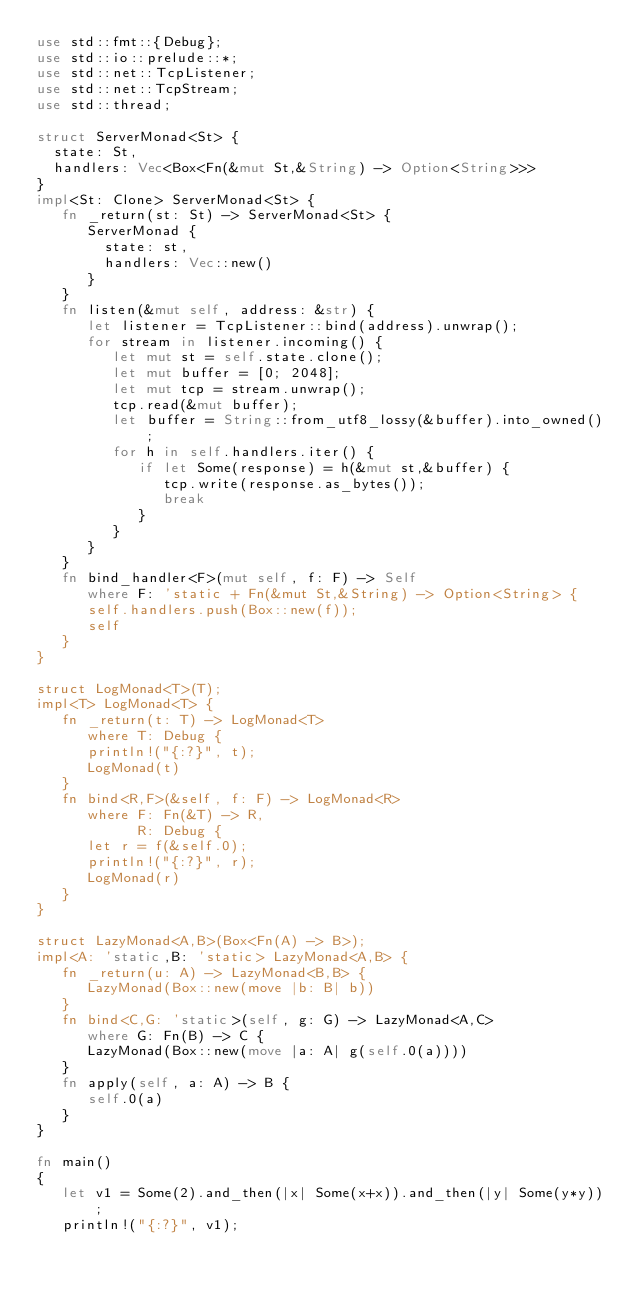Convert code to text. <code><loc_0><loc_0><loc_500><loc_500><_Rust_>use std::fmt::{Debug};
use std::io::prelude::*;
use std::net::TcpListener;
use std::net::TcpStream;
use std::thread;

struct ServerMonad<St> {
  state: St,
  handlers: Vec<Box<Fn(&mut St,&String) -> Option<String>>>
}
impl<St: Clone> ServerMonad<St> {
   fn _return(st: St) -> ServerMonad<St> {
      ServerMonad {
        state: st,
        handlers: Vec::new()
      }
   }
   fn listen(&mut self, address: &str) {
      let listener = TcpListener::bind(address).unwrap();
      for stream in listener.incoming() {
         let mut st = self.state.clone();
         let mut buffer = [0; 2048];
         let mut tcp = stream.unwrap();
         tcp.read(&mut buffer);
         let buffer = String::from_utf8_lossy(&buffer).into_owned();
         for h in self.handlers.iter() {
            if let Some(response) = h(&mut st,&buffer) { 
               tcp.write(response.as_bytes());
               break
            }
         }
      }
   }
   fn bind_handler<F>(mut self, f: F) -> Self
      where F: 'static + Fn(&mut St,&String) -> Option<String> {
      self.handlers.push(Box::new(f));
      self
   }
}

struct LogMonad<T>(T);
impl<T> LogMonad<T> {
   fn _return(t: T) -> LogMonad<T>
      where T: Debug {
      println!("{:?}", t);
      LogMonad(t)
   }
   fn bind<R,F>(&self, f: F) -> LogMonad<R>
      where F: Fn(&T) -> R,
            R: Debug {
      let r = f(&self.0);
      println!("{:?}", r);
      LogMonad(r)
   }
}

struct LazyMonad<A,B>(Box<Fn(A) -> B>);
impl<A: 'static,B: 'static> LazyMonad<A,B> {
   fn _return(u: A) -> LazyMonad<B,B> {
      LazyMonad(Box::new(move |b: B| b))
   }
   fn bind<C,G: 'static>(self, g: G) -> LazyMonad<A,C>
      where G: Fn(B) -> C {
      LazyMonad(Box::new(move |a: A| g(self.0(a))))
   }
   fn apply(self, a: A) -> B {
      self.0(a)
   }
}

fn main() 
{
   let v1 = Some(2).and_then(|x| Some(x+x)).and_then(|y| Some(y*y));
   println!("{:?}", v1);
</code> 